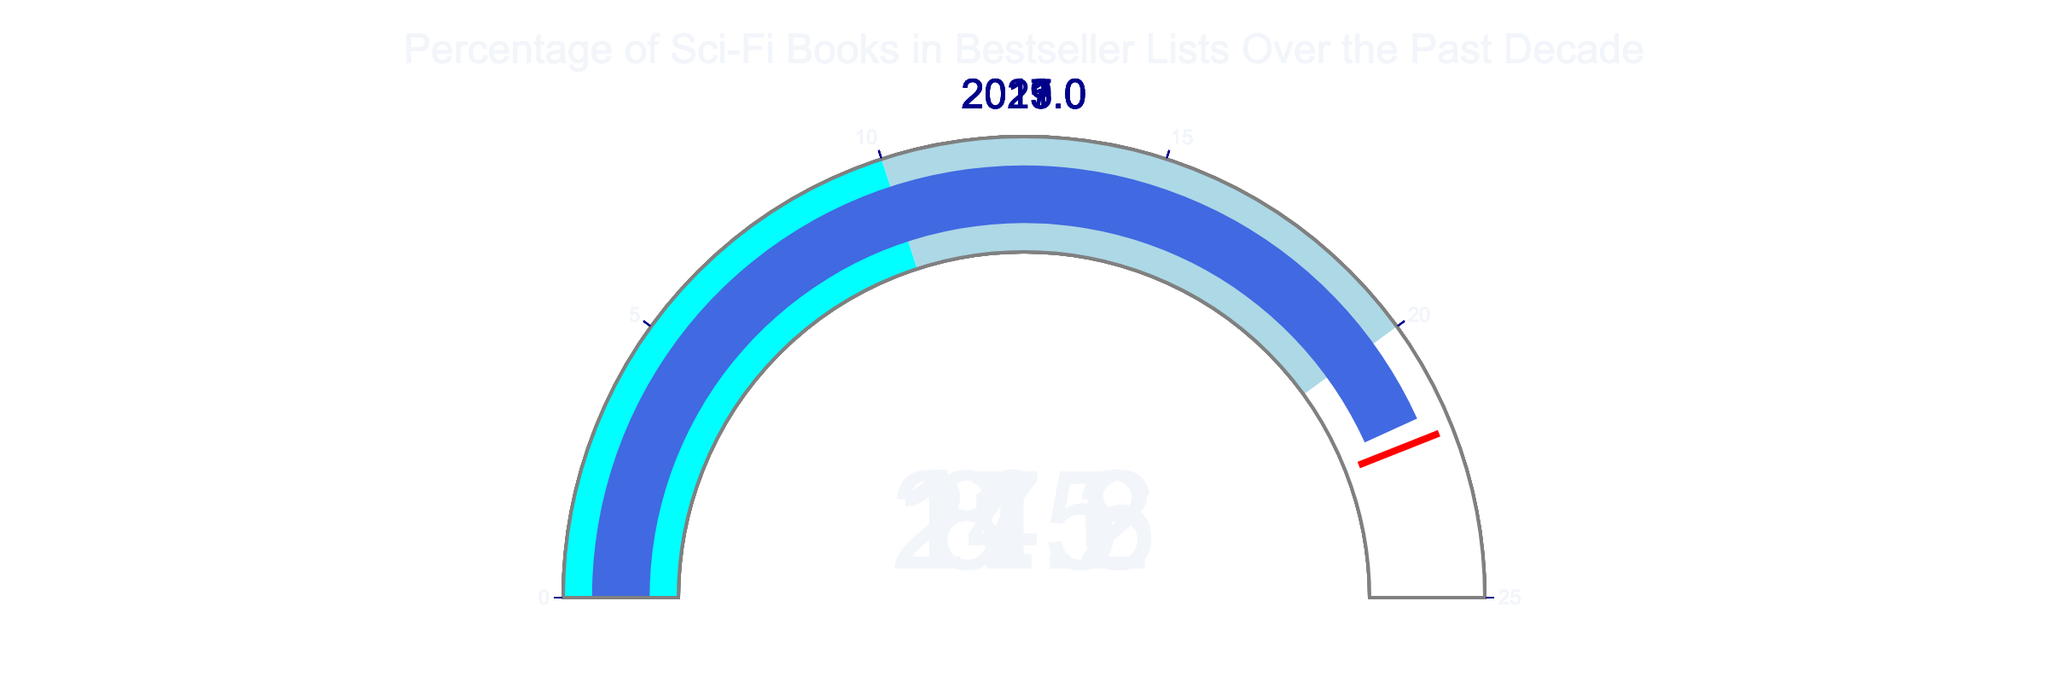What is the highest percentage of sci-fi books in bestseller lists over the past decade? The highest percentage is visually identifiable in the gauge labeled 2021. The value shown on the gauge for 2021 is 21.6%.
Answer: 21.6% What year had the lowest percentage of sci-fi books in bestseller lists? By comparing the values across all gauges, the lowest percentage is in the gauge labeled 2013, which shows 8.5%.
Answer: 8.5% What is the average percentage of sci-fi books in bestseller lists over these years? The percentages are 8.5%, 11.2%, 14.8%, 17.3%, and 21.6%. Summing them up: 8.5 + 11.2 + 14.8 + 17.3 + 21.6 = 73.4. The average is 73.4 / 5 = 14.68.
Answer: 14.68 How much did the percentage of sci-fi books in bestseller lists increase from 2013 to 2021? The percentage in 2021 is 21.6%, and in 2013 it is 8.5%. The increase is calculated as 21.6 - 8.5 = 13.1%.
Answer: 13.1% Which year had a percentage of sci-fi books less than 15%? The gauges for the years 2013 (8.5%), 2015 (11.2%), and 2017 (14.8%) all show percentages less than 15%.
Answer: 2013, 2015, 2017 Are there any years where the percentage of sci-fi books in bestseller lists falls in the cyan-colored range? The cyan-colored range represents percentages 0-10%. The only year that falls within this range is 2013.
Answer: 2013 By how much did the percentage of sci-fi books in bestseller lists increase from 2015 to 2017? The percentage in 2015 is 11.2%, and in 2017 it is 14.8%. The increase is 14.8 - 11.2 = 3.6%.
Answer: 3.6% Is the percentage of sci-fi books in bestseller lists closer to the threshold value in 2021 or 2019? The threshold value is 22%. In 2021, the percentage is 21.6%, which is 0.4% away. In 2019, the percentage is 17.3%, which is 4.7% away. Therefore, 2021 is closer to the threshold.
Answer: 2021 Which year is just below the threshold indicated on the gauges? The threshold line is at 22%. The year closest below this value is 2021, with 21.6%.
Answer: 2021 